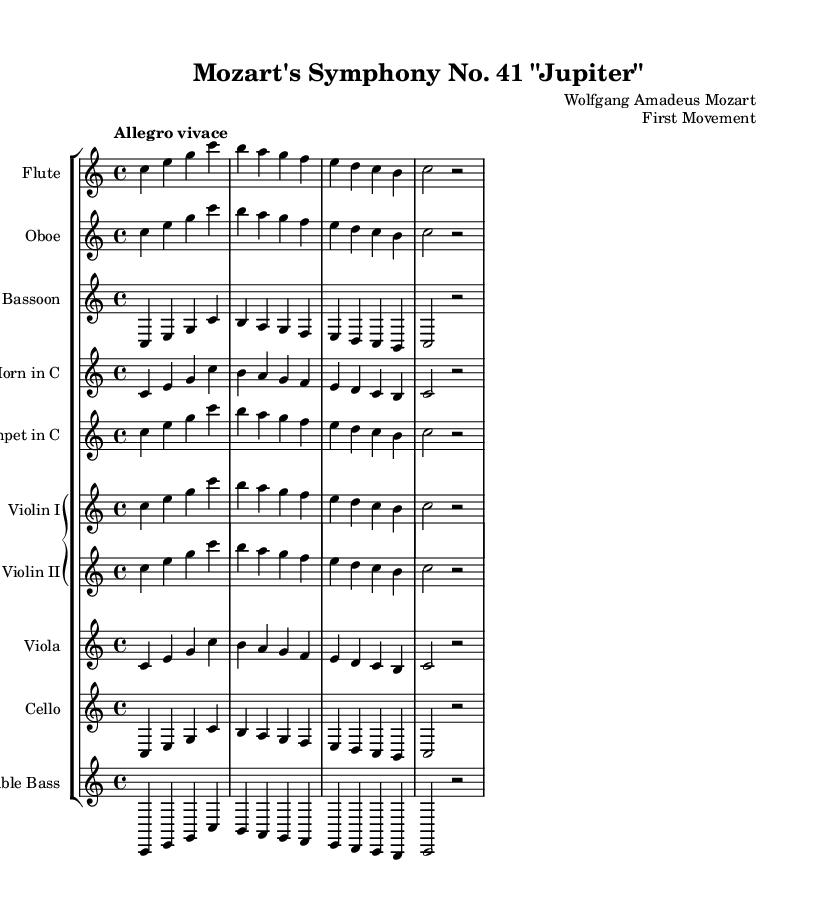What is the key signature of this music? The key signature is shown at the beginning of the staff and indicates C major, which has no sharps or flats.
Answer: C major What is the time signature of this music? The time signature appears at the start of the music, denoting it as 4/4, indicating four beats per measure.
Answer: 4/4 What is the tempo marking of this music? The tempo marking is found above the staff and specifies "Allegro vivace," indicating a lively and fast tempo.
Answer: Allegro vivace How many staves are present in the score? By counting the individual staves listed in the score, there are a total of 10 staves comprising the various instruments.
Answer: 10 Which instrument has the lowest pitch range in this score? Among the instruments notated, the double bass, which has a lower written pitch compared to others, plays the lowest notes.
Answer: Double Bass Identify one way in which the harmonies are described in this symphony. The harmony is complex due to the combination of melodic lines and full orchestration, which creates rich textures and interactions among instruments.
Answer: Complex What is unique about the structure of this symphony compared to typical symphonic forms? This symphony showcases a clear structure coupled with intricate thematic development and counterpoint, contributing to its unique character within symphonic music.
Answer: Clear structure 